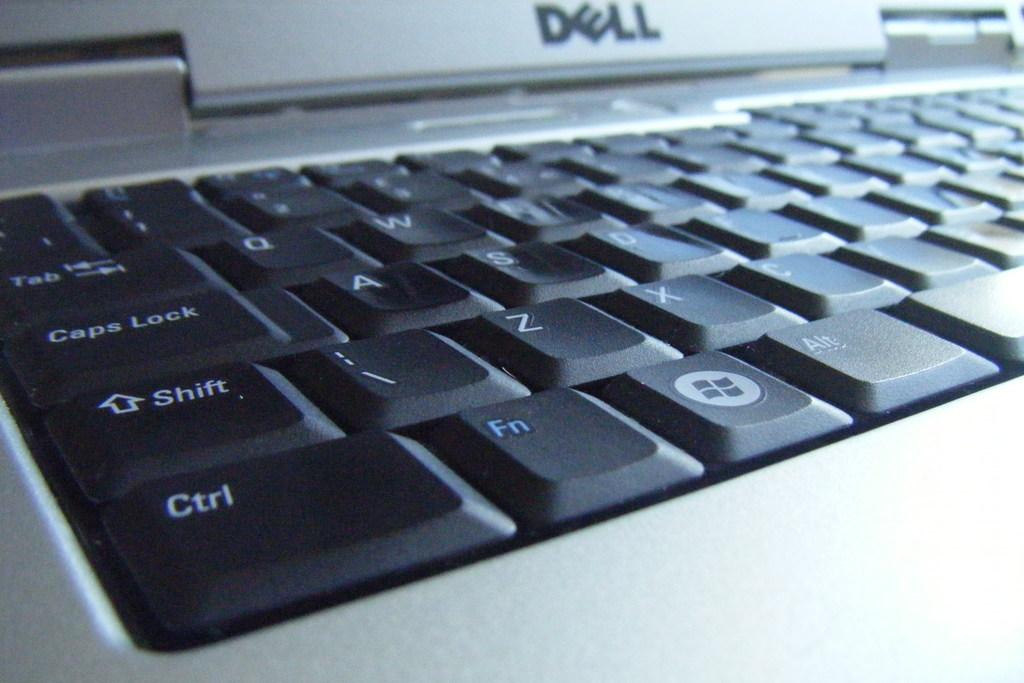What computer brand is shown?
Provide a succinct answer. Dell. What is the first key on the bottom left?
Offer a terse response. Ctrl. 